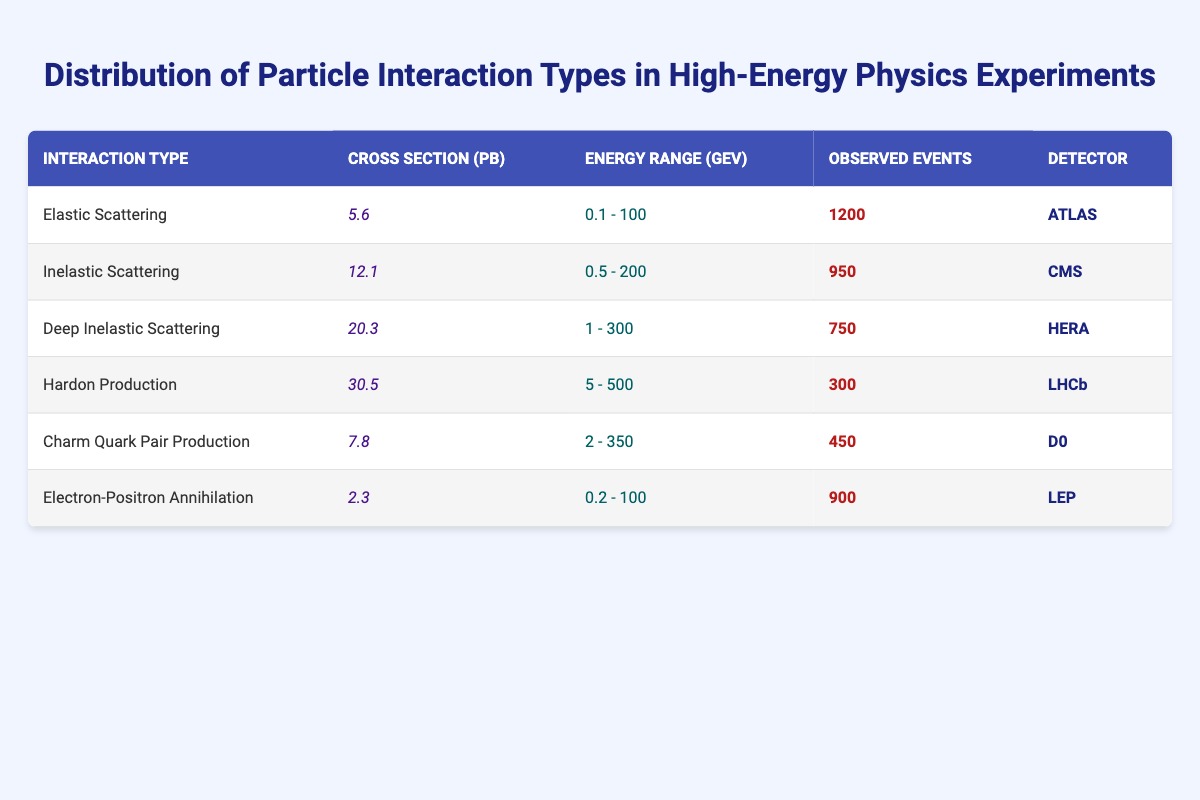What is the cross-section for Deep Inelastic Scattering? The table lists the cross-section for each interaction type. For Deep Inelastic Scattering, the value given is 20.3 pb.
Answer: 20.3 pb Which detector observed the highest number of events? By comparing the 'Observed Events' column, ATLAS recorded the highest number at 1200 events.
Answer: ATLAS What is the average cross-section for the particle interactions in the table? To find the average cross-section, sum all the cross-section values: (5.6 + 12.1 + 20.3 + 30.5 + 7.8 + 2.3) = 78.6 pb. There are 6 interaction types, so the average is 78.6/6 = 13.1 pb.
Answer: 13.1 pb Is the cross-section for Hardon Production greater than the sum of the cross-sections for Elastic and Inelastic Scattering? The cross-section for Hardon Production is 30.5 pb. The sum of Elastic Scattering (5.6 pb) and Inelastic Scattering (12.1 pb) is 17.7 pb. Since 30.5 is greater than 17.7, the statement is true.
Answer: Yes How many observed events are reported for all the interactions identified in the table? To find the total observed events, sum the values in the 'Observed Events' column: (1200 + 950 + 750 + 300 + 450 + 900) = 3850.
Answer: 3850 